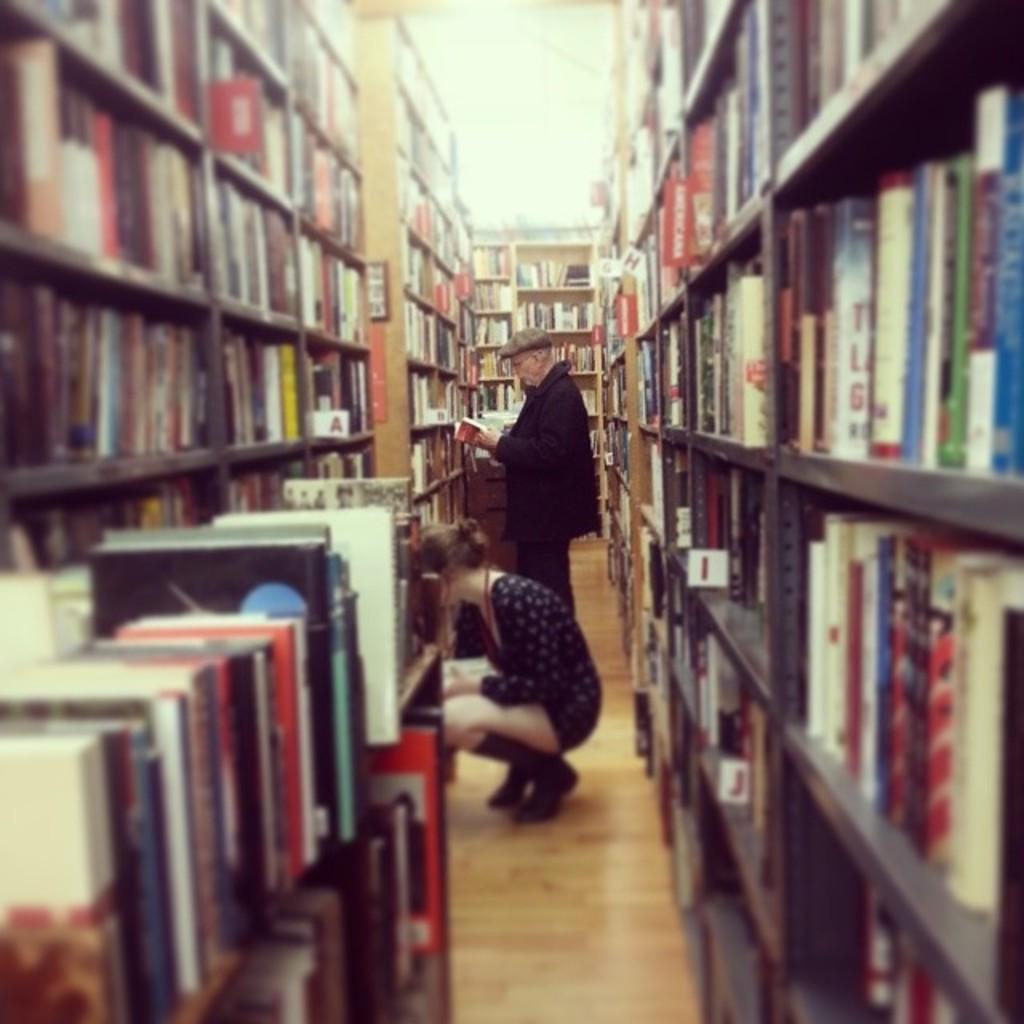What letter corresponds to the second lowest shelf on the right?
Offer a terse response. J. What letter is shown on the left shelf?
Keep it short and to the point. A. 